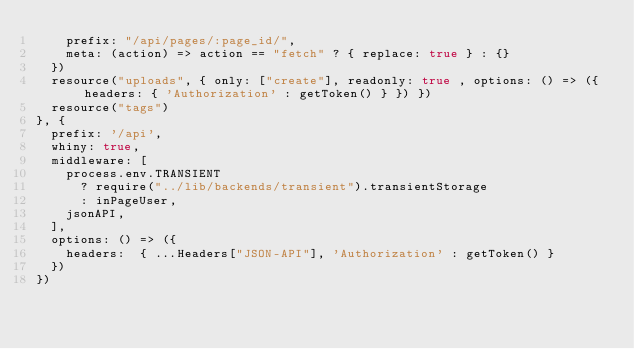<code> <loc_0><loc_0><loc_500><loc_500><_JavaScript_>    prefix: "/api/pages/:page_id/",
    meta: (action) => action == "fetch" ? { replace: true } : {}
  })
  resource("uploads", { only: ["create"], readonly: true , options: () => ({ headers: { 'Authorization' : getToken() } }) })
  resource("tags")
}, {
  prefix: '/api',
  whiny: true,
  middleware: [
    process.env.TRANSIENT
      ? require("../lib/backends/transient").transientStorage
      : inPageUser,
    jsonAPI,
  ],
  options: () => ({
    headers:  { ...Headers["JSON-API"], 'Authorization' : getToken() }
  })
})
</code> 